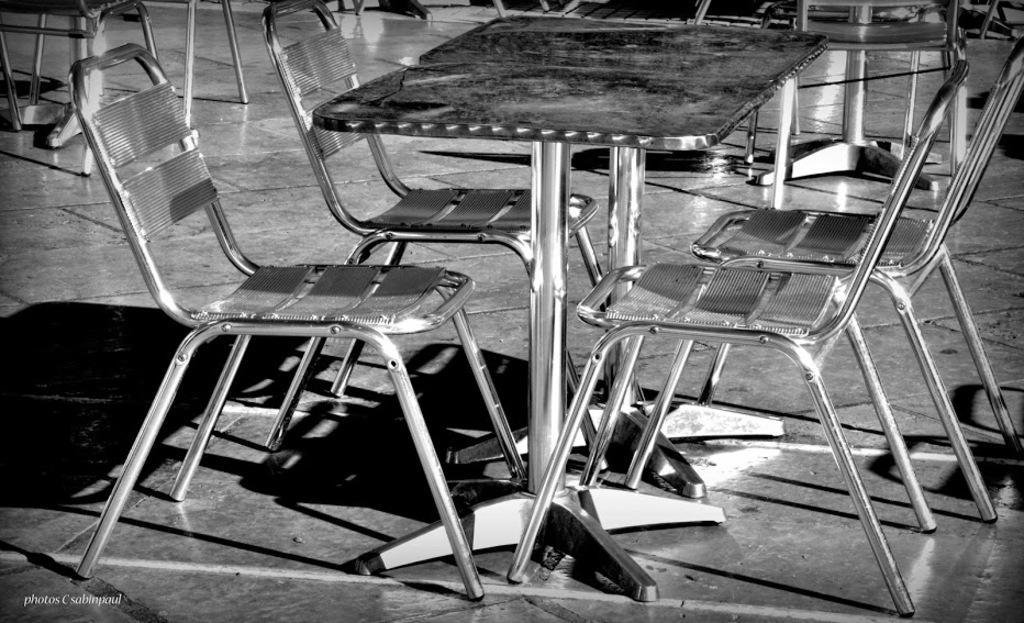How would you summarize this image in a sentence or two? This picture shows a few metal chairs and tables. 